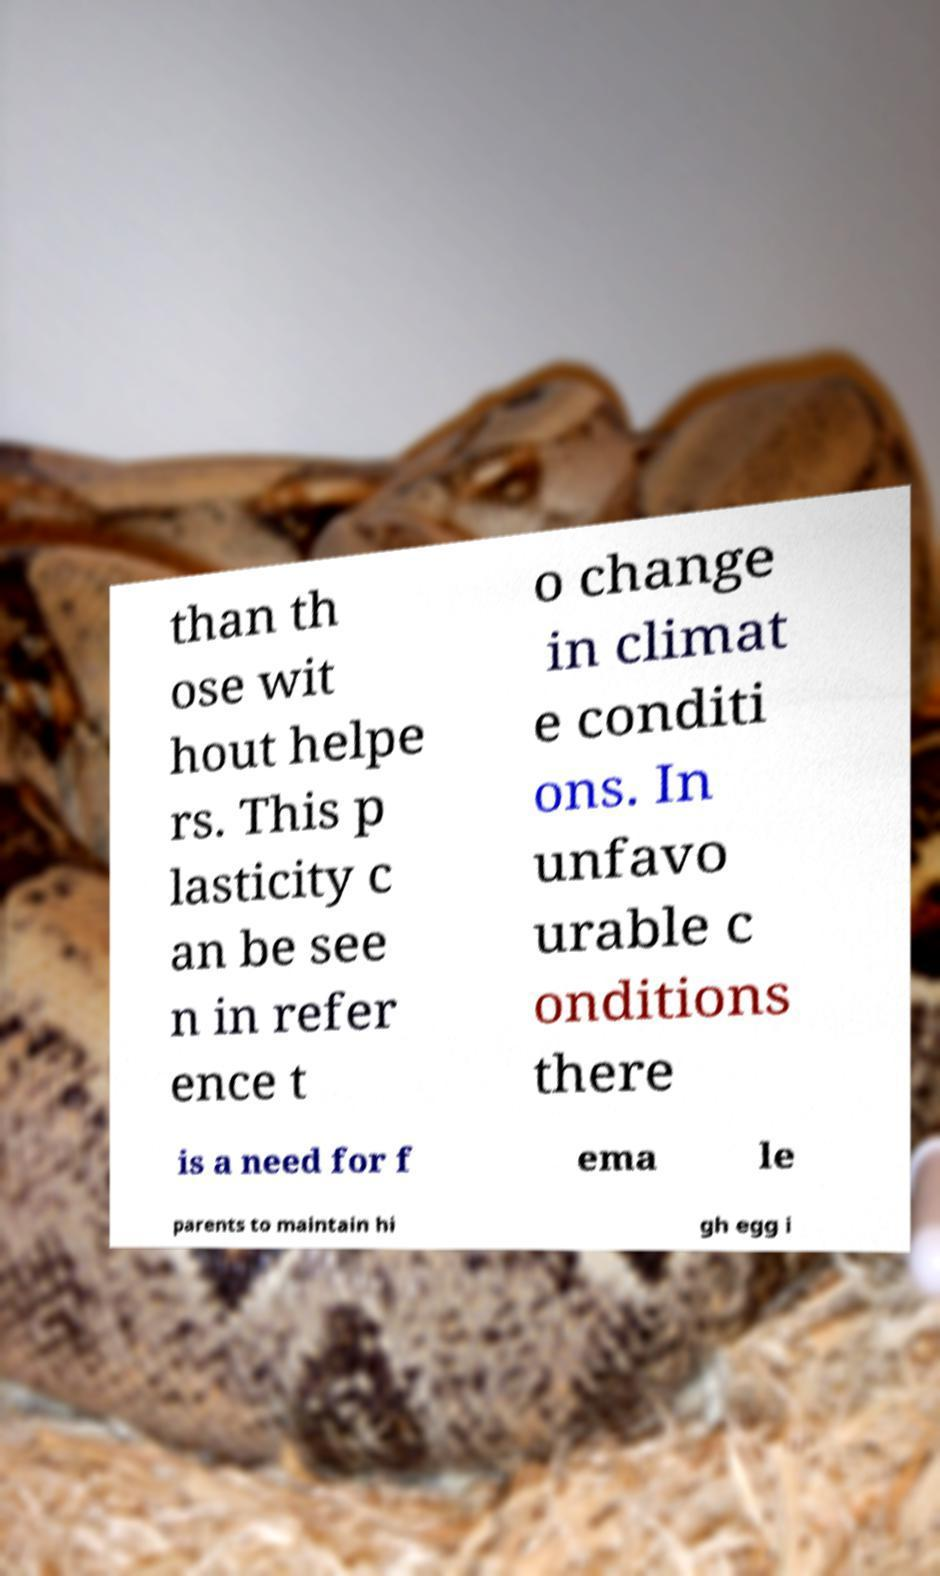Could you assist in decoding the text presented in this image and type it out clearly? than th ose wit hout helpe rs. This p lasticity c an be see n in refer ence t o change in climat e conditi ons. In unfavo urable c onditions there is a need for f ema le parents to maintain hi gh egg i 